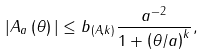Convert formula to latex. <formula><loc_0><loc_0><loc_500><loc_500>| A _ { a } \left ( \theta \right ) | \leq b _ { ( A , k ) } \frac { a ^ { - 2 } } { 1 + \left ( \theta / a \right ) ^ { k } } ,</formula> 